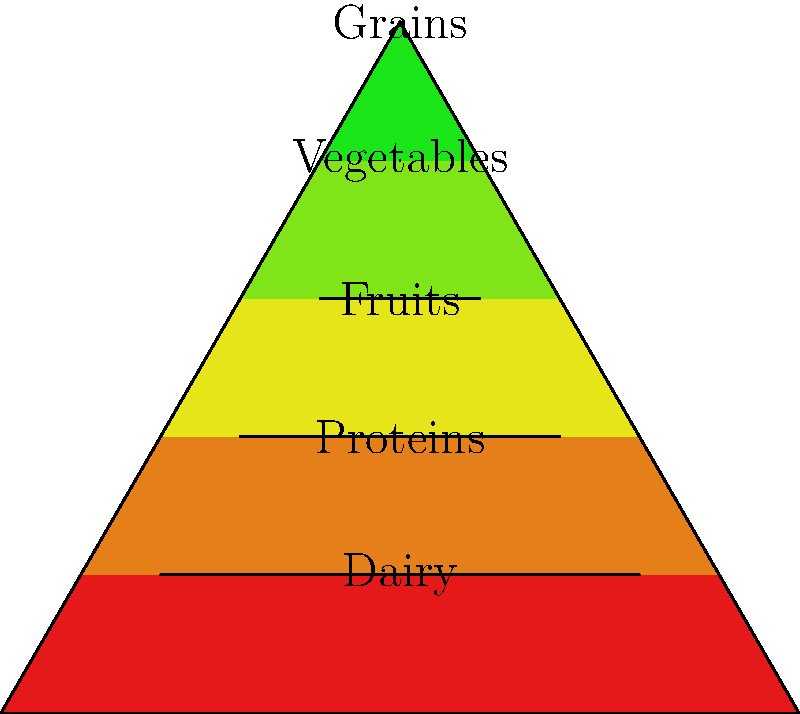Based on the food pyramid diagram, which food group should form the largest portion of a balanced diet, and what does this suggest about its importance in daily nutrient intake? To answer this question, we need to analyze the food pyramid diagram and understand its structure:

1. The pyramid is divided into five sections, each representing a different food group.

2. The sections are arranged from bottom to top, with the largest section at the base and the smallest at the top.

3. The food groups, from bottom to top, are:
   a. Grains (largest section)
   b. Vegetables
   c. Fruits
   d. Proteins
   e. Dairy (smallest section)

4. The size of each section represents the recommended proportion of that food group in a balanced diet.

5. The largest section at the base of the pyramid is the Grains group, indicating that it should form the largest portion of a balanced diet.

6. This placement and size suggest that grains are essential for daily nutrient intake due to several factors:
   a. They provide complex carbohydrates, which are the body's primary source of energy.
   b. Whole grains offer important nutrients such as fiber, B vitamins, and minerals.
   c. They form the foundation of many cultural diets worldwide.

7. However, it's important to note that modern nutritional guidelines often emphasize the quality of grains (e.g., whole grains over refined grains) rather than just quantity.

8. The pyramid also emphasizes the importance of a varied diet, with substantial portions of vegetables and fruits, and smaller amounts of proteins and dairy.
Answer: Grains; they provide essential energy and nutrients as the foundation of a balanced diet. 